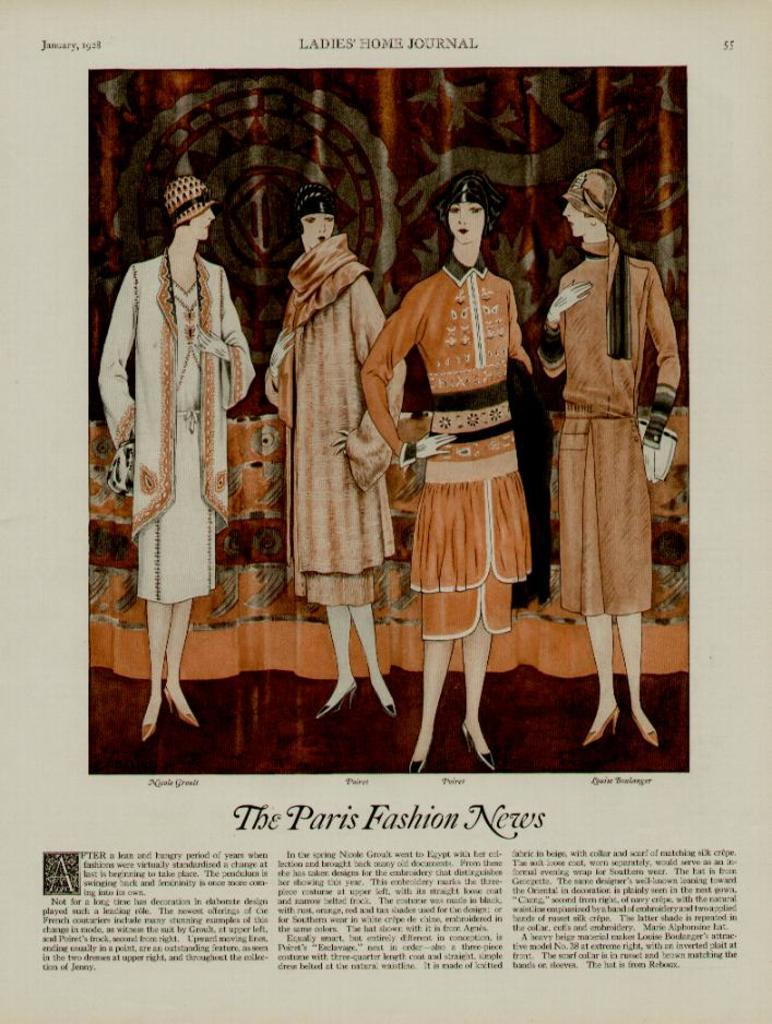What is the main object in the image? There is a paper in the image. What type of content is on the paper? The paper contains pictures of women. Is there any text on the paper? Yes, there is text written on the paper. How many cows are attacking the women in the image? There are no cows or attacks depicted in the image; it features a paper with pictures of women and text. 